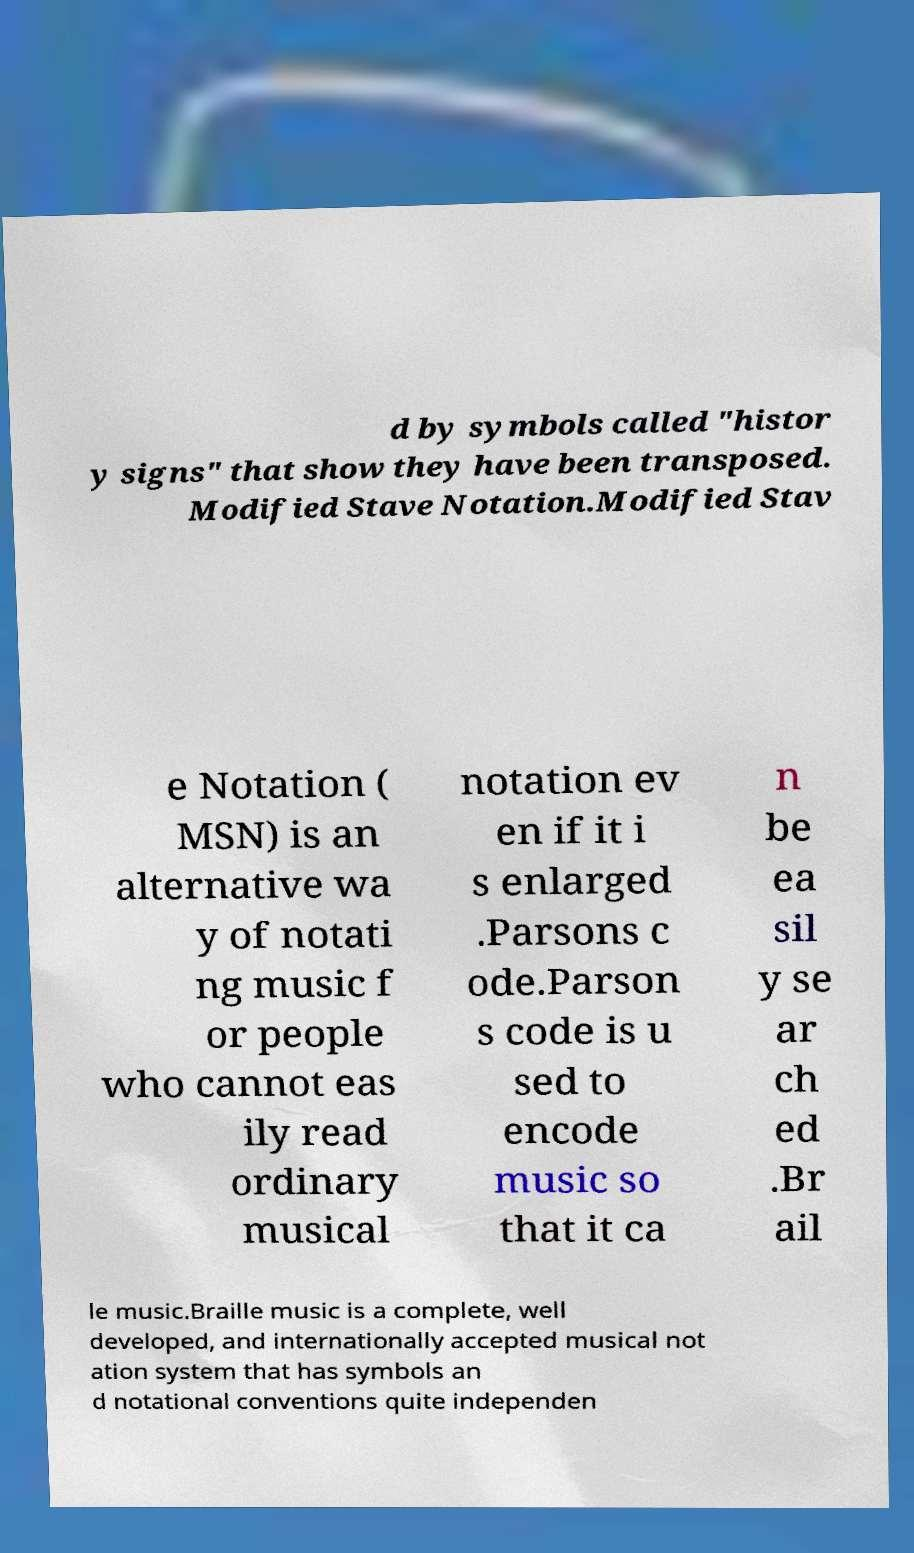Can you accurately transcribe the text from the provided image for me? d by symbols called "histor y signs" that show they have been transposed. Modified Stave Notation.Modified Stav e Notation ( MSN) is an alternative wa y of notati ng music f or people who cannot eas ily read ordinary musical notation ev en if it i s enlarged .Parsons c ode.Parson s code is u sed to encode music so that it ca n be ea sil y se ar ch ed .Br ail le music.Braille music is a complete, well developed, and internationally accepted musical not ation system that has symbols an d notational conventions quite independen 